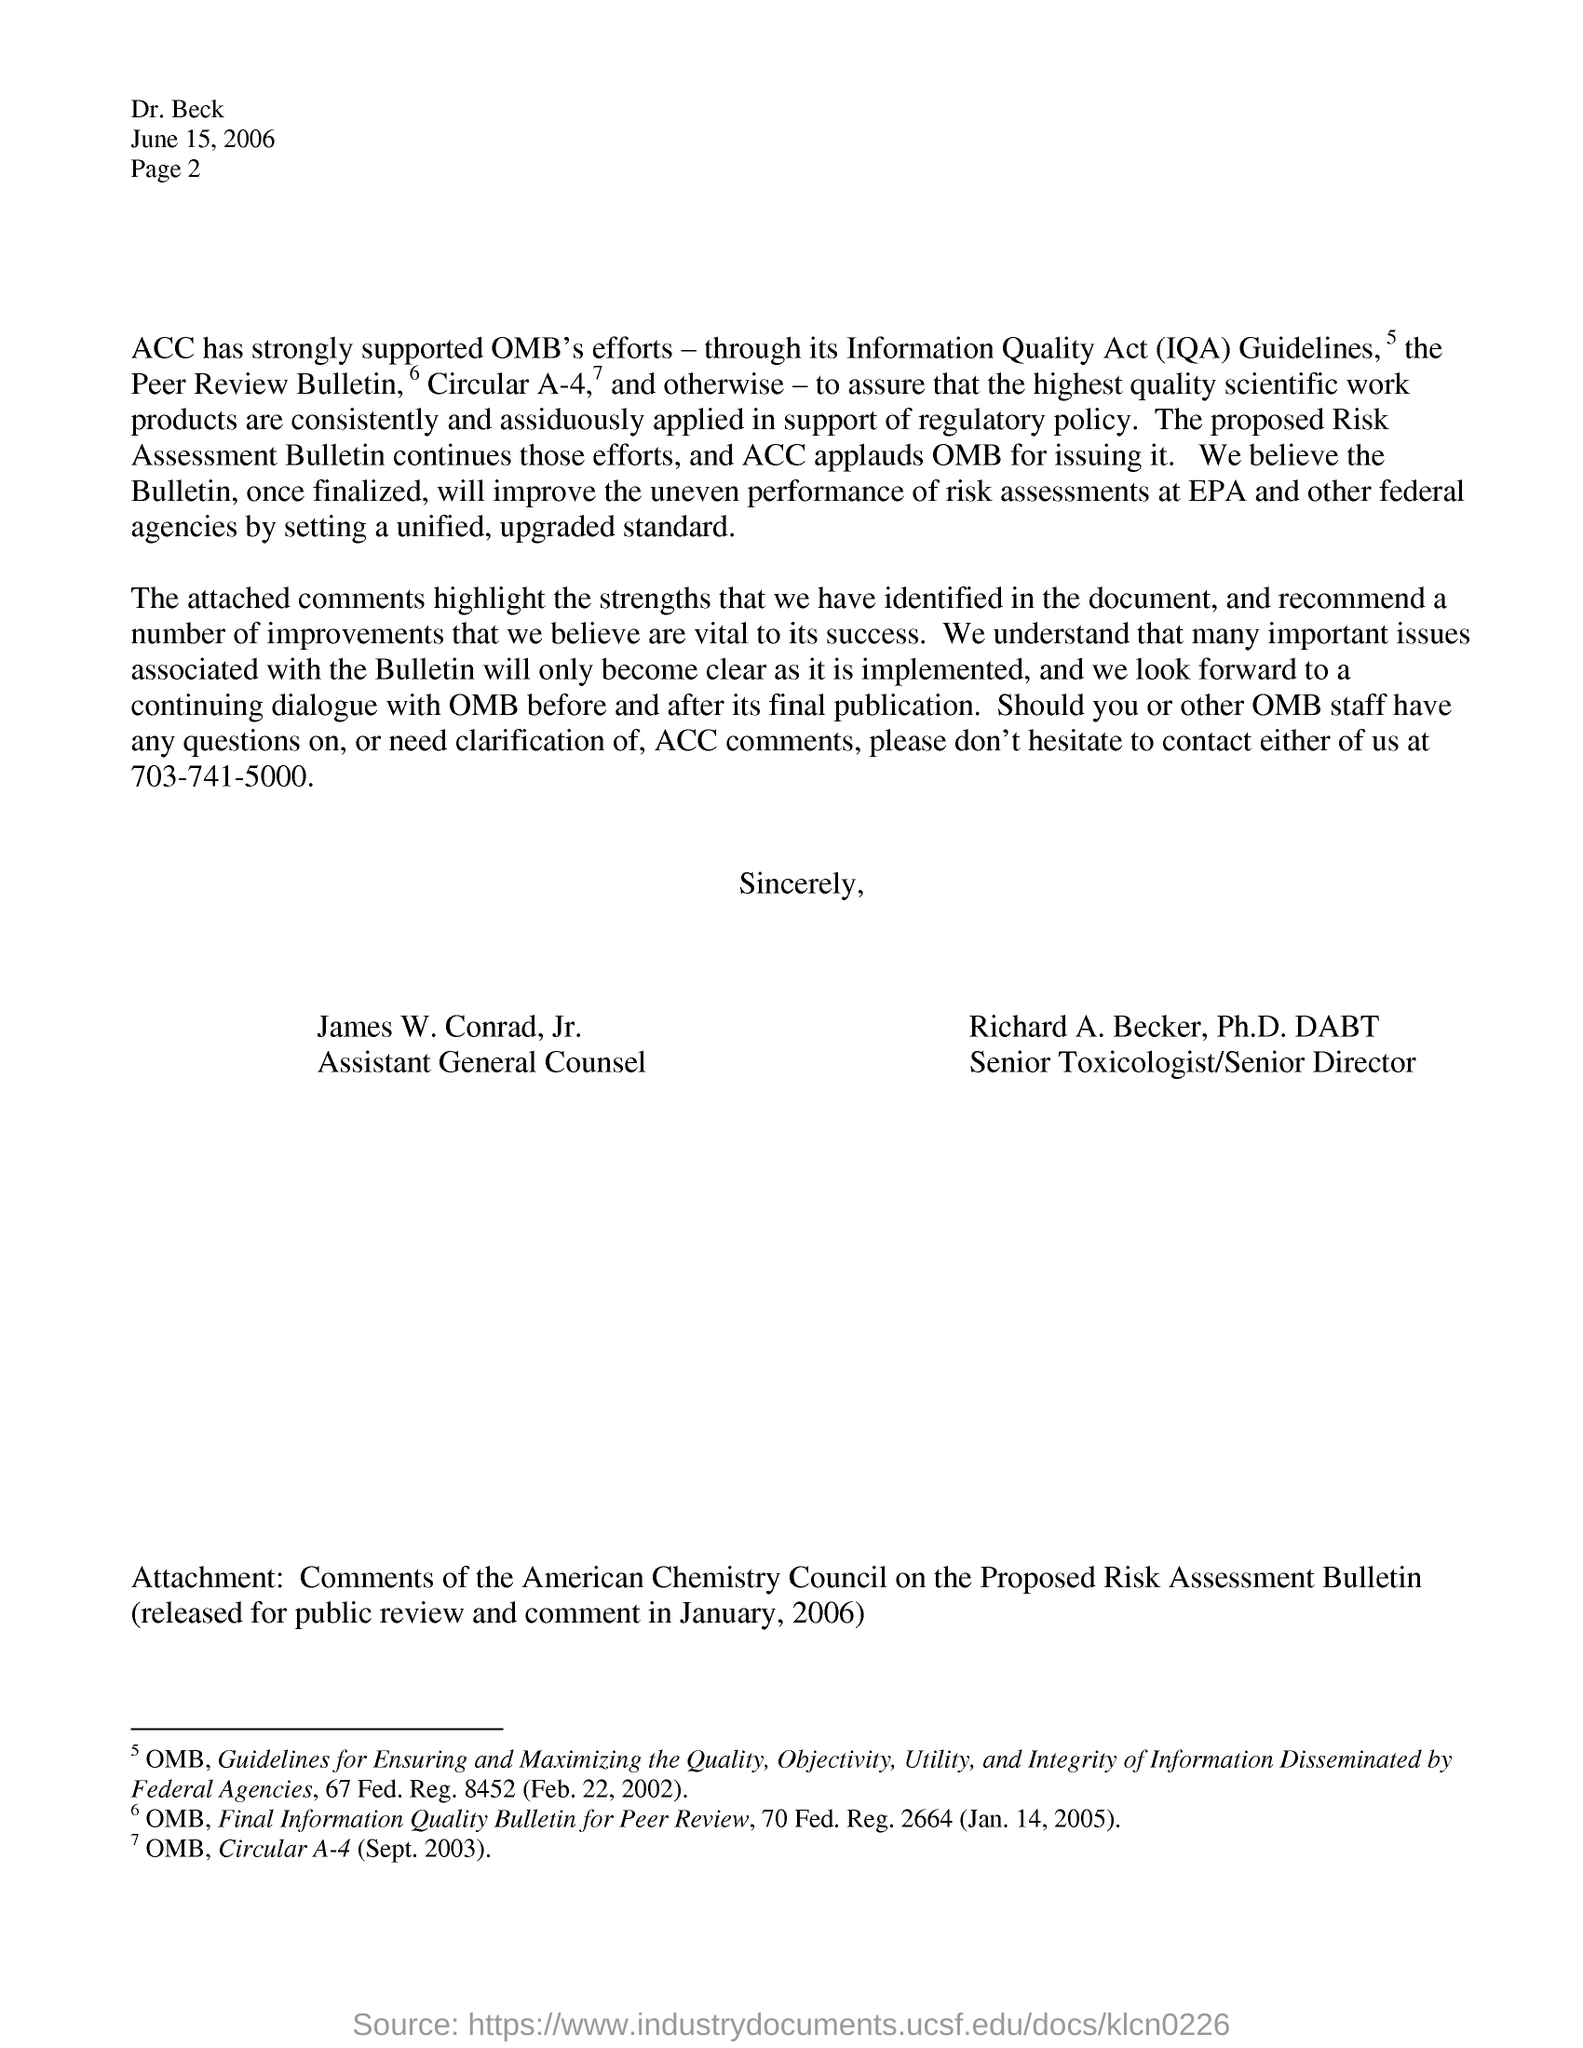Mention the date which is on right side top of the letter
Your response must be concise. JUNE 15, 2006. What does iqa stands for?
Your response must be concise. Information quality act. Who is assistant general counsel?
Your answer should be very brief. James w.conrad, jr. Who is the senior toxicologist/senior director?
Your response must be concise. RICHARD A. BECKER. Which has strongly supported omb's efforts through its information quality act iqa guidelines?
Make the answer very short. ACC. 